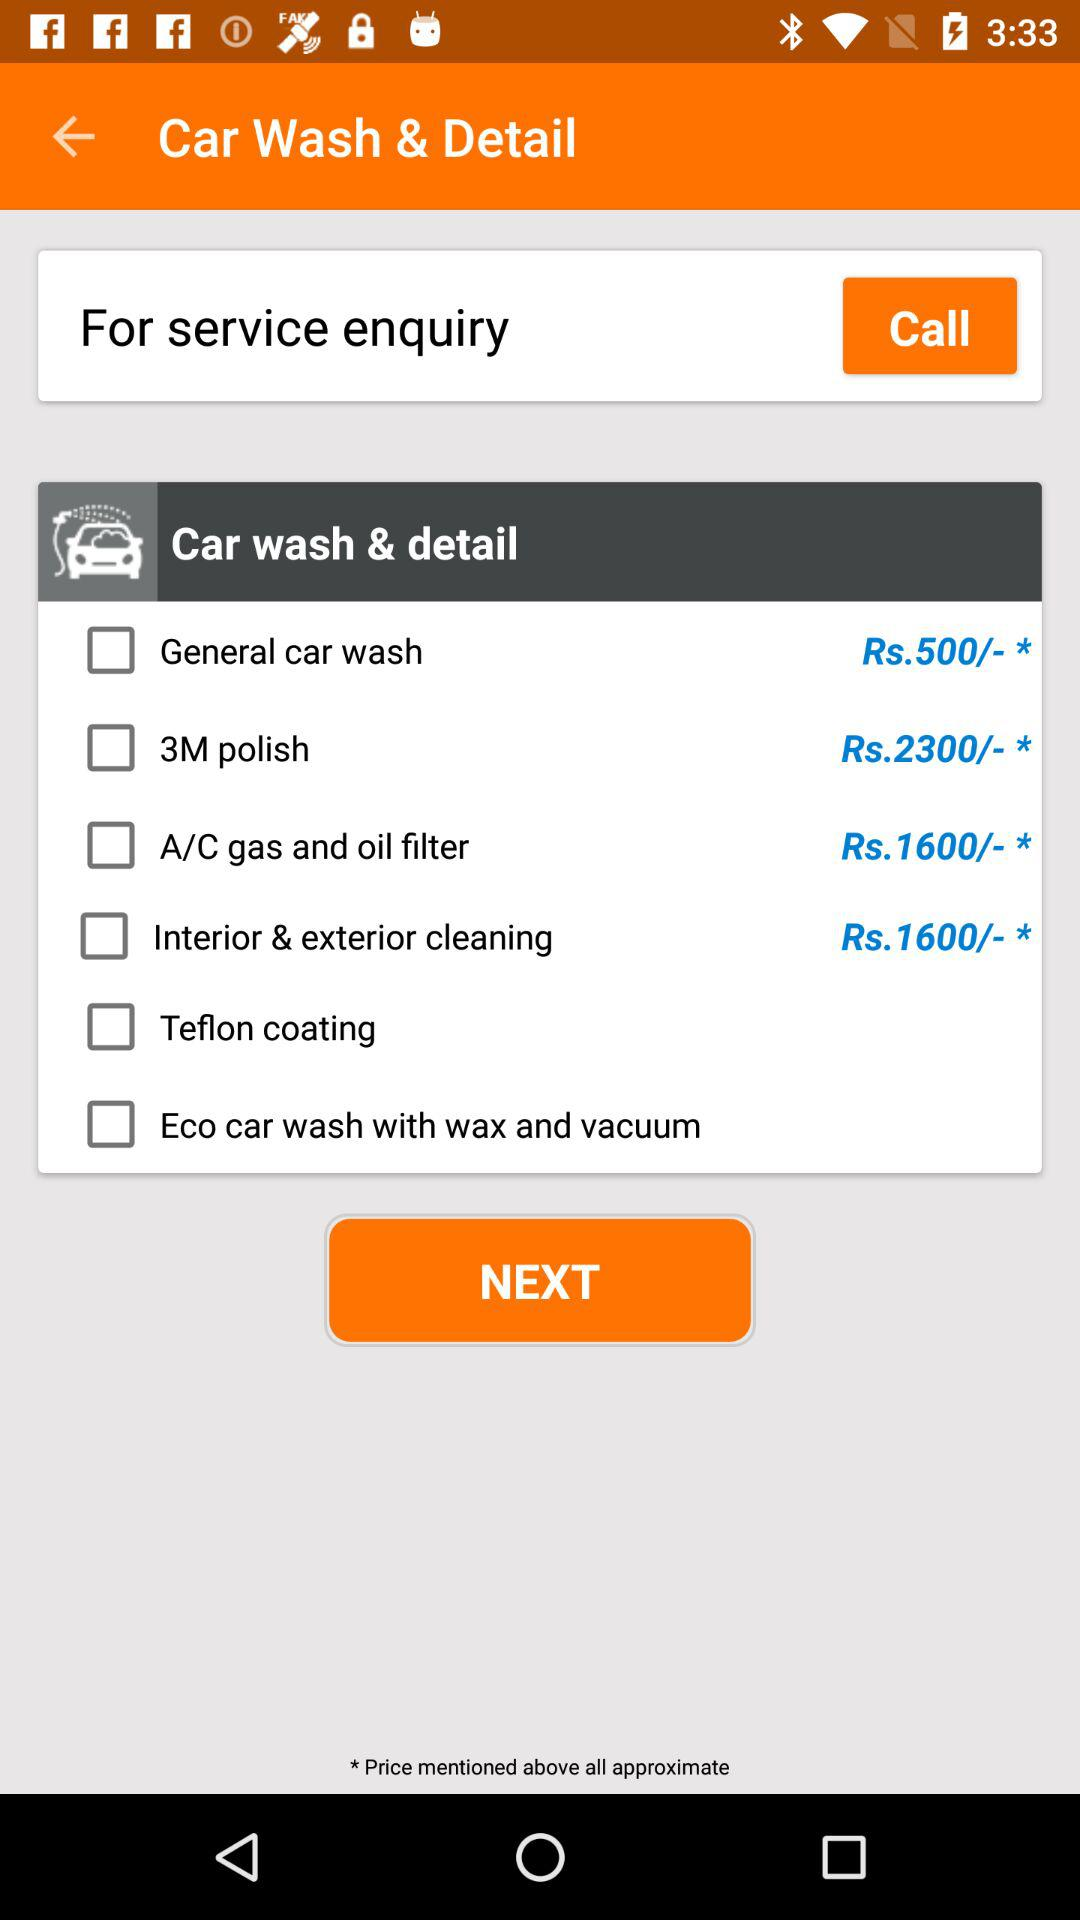How much does the "A/C gas and oil filter" cost? It costs 1,600 rupees. 